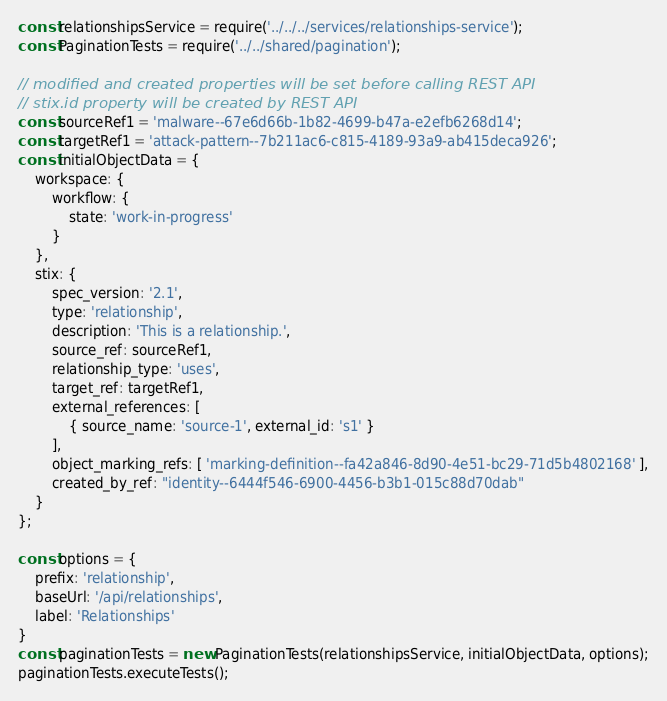Convert code to text. <code><loc_0><loc_0><loc_500><loc_500><_JavaScript_>const relationshipsService = require('../../../services/relationships-service');
const PaginationTests = require('../../shared/pagination');

// modified and created properties will be set before calling REST API
// stix.id property will be created by REST API
const sourceRef1 = 'malware--67e6d66b-1b82-4699-b47a-e2efb6268d14';
const targetRef1 = 'attack-pattern--7b211ac6-c815-4189-93a9-ab415deca926';
const initialObjectData = {
    workspace: {
        workflow: {
            state: 'work-in-progress'
        }
    },
    stix: {
        spec_version: '2.1',
        type: 'relationship',
        description: 'This is a relationship.',
        source_ref: sourceRef1,
        relationship_type: 'uses',
        target_ref: targetRef1,
        external_references: [
            { source_name: 'source-1', external_id: 's1' }
        ],
        object_marking_refs: [ 'marking-definition--fa42a846-8d90-4e51-bc29-71d5b4802168' ],
        created_by_ref: "identity--6444f546-6900-4456-b3b1-015c88d70dab"
    }
};

const options = {
    prefix: 'relationship',
    baseUrl: '/api/relationships',
    label: 'Relationships'
}
const paginationTests = new PaginationTests(relationshipsService, initialObjectData, options);
paginationTests.executeTests();
</code> 